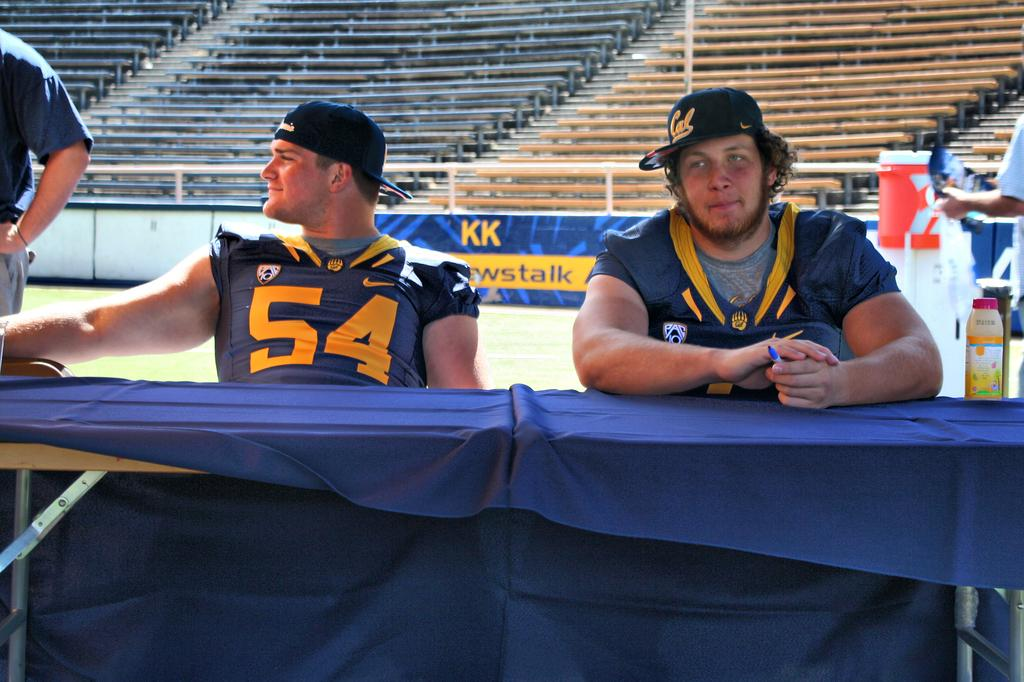<image>
Create a compact narrative representing the image presented. A player holding a pen sits at a table next to player number fifty four. 